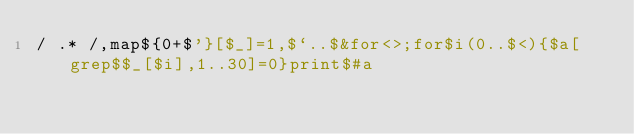Convert code to text. <code><loc_0><loc_0><loc_500><loc_500><_Perl_>/ .* /,map${0+$'}[$_]=1,$`..$&for<>;for$i(0..$<){$a[grep$$_[$i],1..30]=0}print$#a</code> 